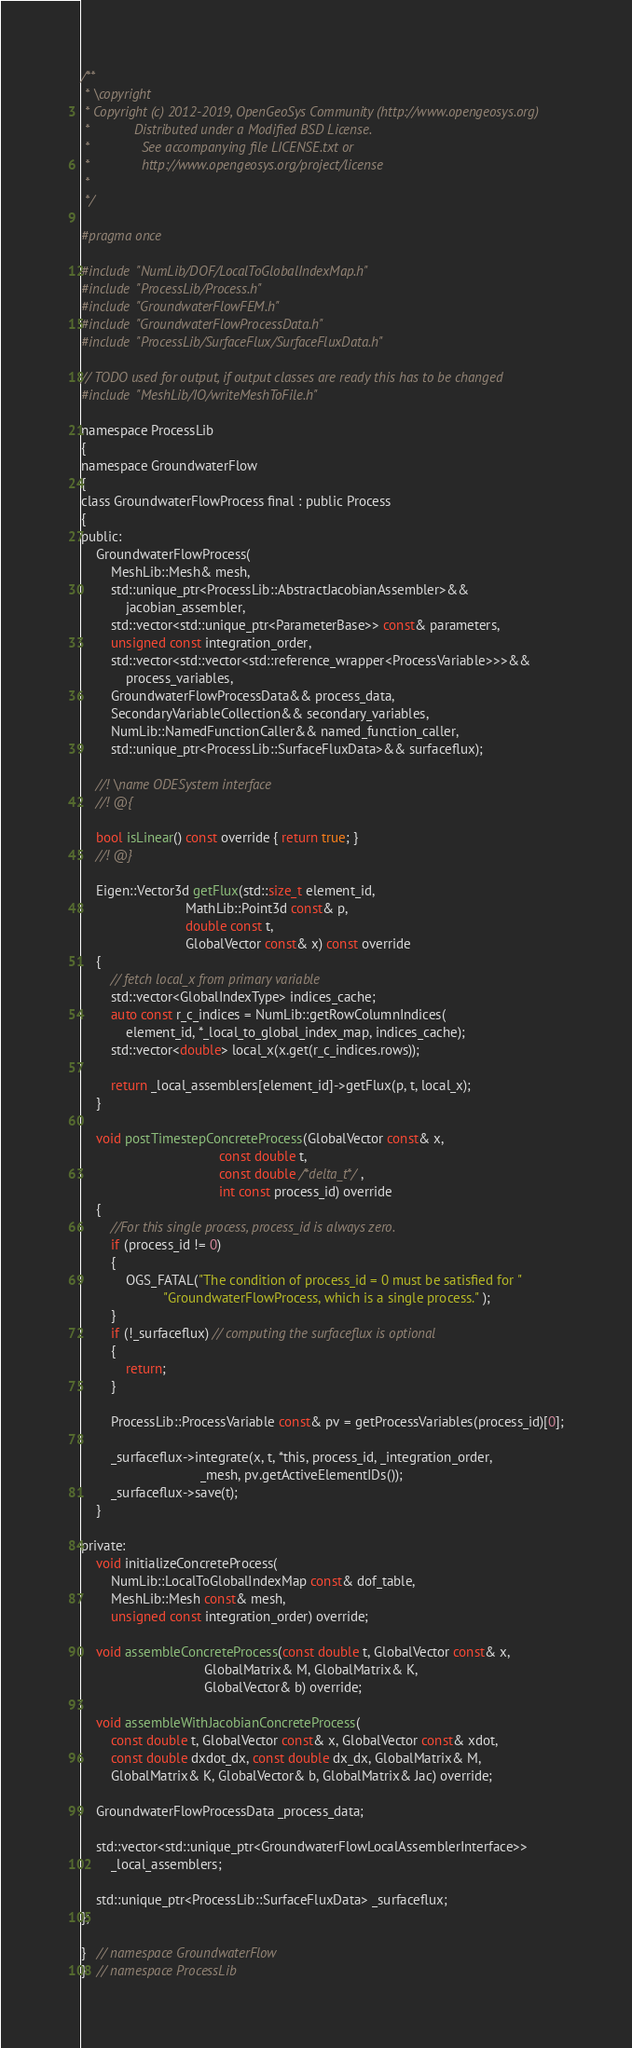<code> <loc_0><loc_0><loc_500><loc_500><_C_>/**
 * \copyright
 * Copyright (c) 2012-2019, OpenGeoSys Community (http://www.opengeosys.org)
 *            Distributed under a Modified BSD License.
 *              See accompanying file LICENSE.txt or
 *              http://www.opengeosys.org/project/license
 *
 */

#pragma once

#include "NumLib/DOF/LocalToGlobalIndexMap.h"
#include "ProcessLib/Process.h"
#include "GroundwaterFlowFEM.h"
#include "GroundwaterFlowProcessData.h"
#include "ProcessLib/SurfaceFlux/SurfaceFluxData.h"

// TODO used for output, if output classes are ready this has to be changed
#include "MeshLib/IO/writeMeshToFile.h"

namespace ProcessLib
{
namespace GroundwaterFlow
{
class GroundwaterFlowProcess final : public Process
{
public:
    GroundwaterFlowProcess(
        MeshLib::Mesh& mesh,
        std::unique_ptr<ProcessLib::AbstractJacobianAssembler>&&
            jacobian_assembler,
        std::vector<std::unique_ptr<ParameterBase>> const& parameters,
        unsigned const integration_order,
        std::vector<std::vector<std::reference_wrapper<ProcessVariable>>>&&
            process_variables,
        GroundwaterFlowProcessData&& process_data,
        SecondaryVariableCollection&& secondary_variables,
        NumLib::NamedFunctionCaller&& named_function_caller,
        std::unique_ptr<ProcessLib::SurfaceFluxData>&& surfaceflux);

    //! \name ODESystem interface
    //! @{

    bool isLinear() const override { return true; }
    //! @}

    Eigen::Vector3d getFlux(std::size_t element_id,
                            MathLib::Point3d const& p,
                            double const t,
                            GlobalVector const& x) const override
    {
        // fetch local_x from primary variable
        std::vector<GlobalIndexType> indices_cache;
        auto const r_c_indices = NumLib::getRowColumnIndices(
            element_id, *_local_to_global_index_map, indices_cache);
        std::vector<double> local_x(x.get(r_c_indices.rows));

        return _local_assemblers[element_id]->getFlux(p, t, local_x);
    }

    void postTimestepConcreteProcess(GlobalVector const& x,
                                     const double t,
                                     const double /*delta_t*/,
                                     int const process_id) override
    {
        //For this single process, process_id is always zero.
        if (process_id != 0)
        {
            OGS_FATAL("The condition of process_id = 0 must be satisfied for "
                      "GroundwaterFlowProcess, which is a single process." );
        }
        if (!_surfaceflux) // computing the surfaceflux is optional
        {
            return;
        }

        ProcessLib::ProcessVariable const& pv = getProcessVariables(process_id)[0];

        _surfaceflux->integrate(x, t, *this, process_id, _integration_order,
                                _mesh, pv.getActiveElementIDs());
        _surfaceflux->save(t);
    }

private:
    void initializeConcreteProcess(
        NumLib::LocalToGlobalIndexMap const& dof_table,
        MeshLib::Mesh const& mesh,
        unsigned const integration_order) override;

    void assembleConcreteProcess(const double t, GlobalVector const& x,
                                 GlobalMatrix& M, GlobalMatrix& K,
                                 GlobalVector& b) override;

    void assembleWithJacobianConcreteProcess(
        const double t, GlobalVector const& x, GlobalVector const& xdot,
        const double dxdot_dx, const double dx_dx, GlobalMatrix& M,
        GlobalMatrix& K, GlobalVector& b, GlobalMatrix& Jac) override;

    GroundwaterFlowProcessData _process_data;

    std::vector<std::unique_ptr<GroundwaterFlowLocalAssemblerInterface>>
        _local_assemblers;

    std::unique_ptr<ProcessLib::SurfaceFluxData> _surfaceflux;
};

}   // namespace GroundwaterFlow
}   // namespace ProcessLib
</code> 